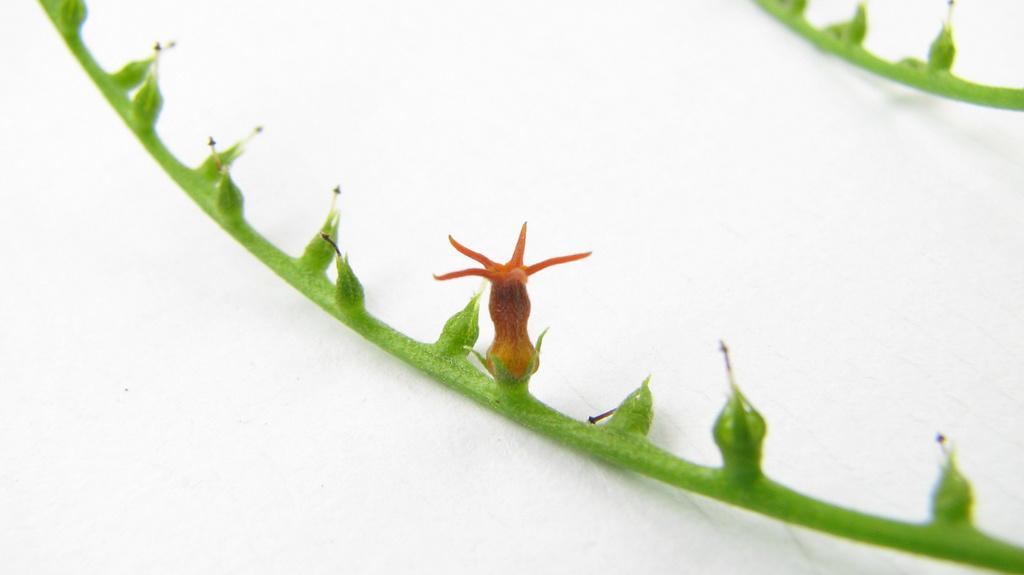Please provide a concise description of this image. In this image I can see 2 stems and a flower on a white surface. 